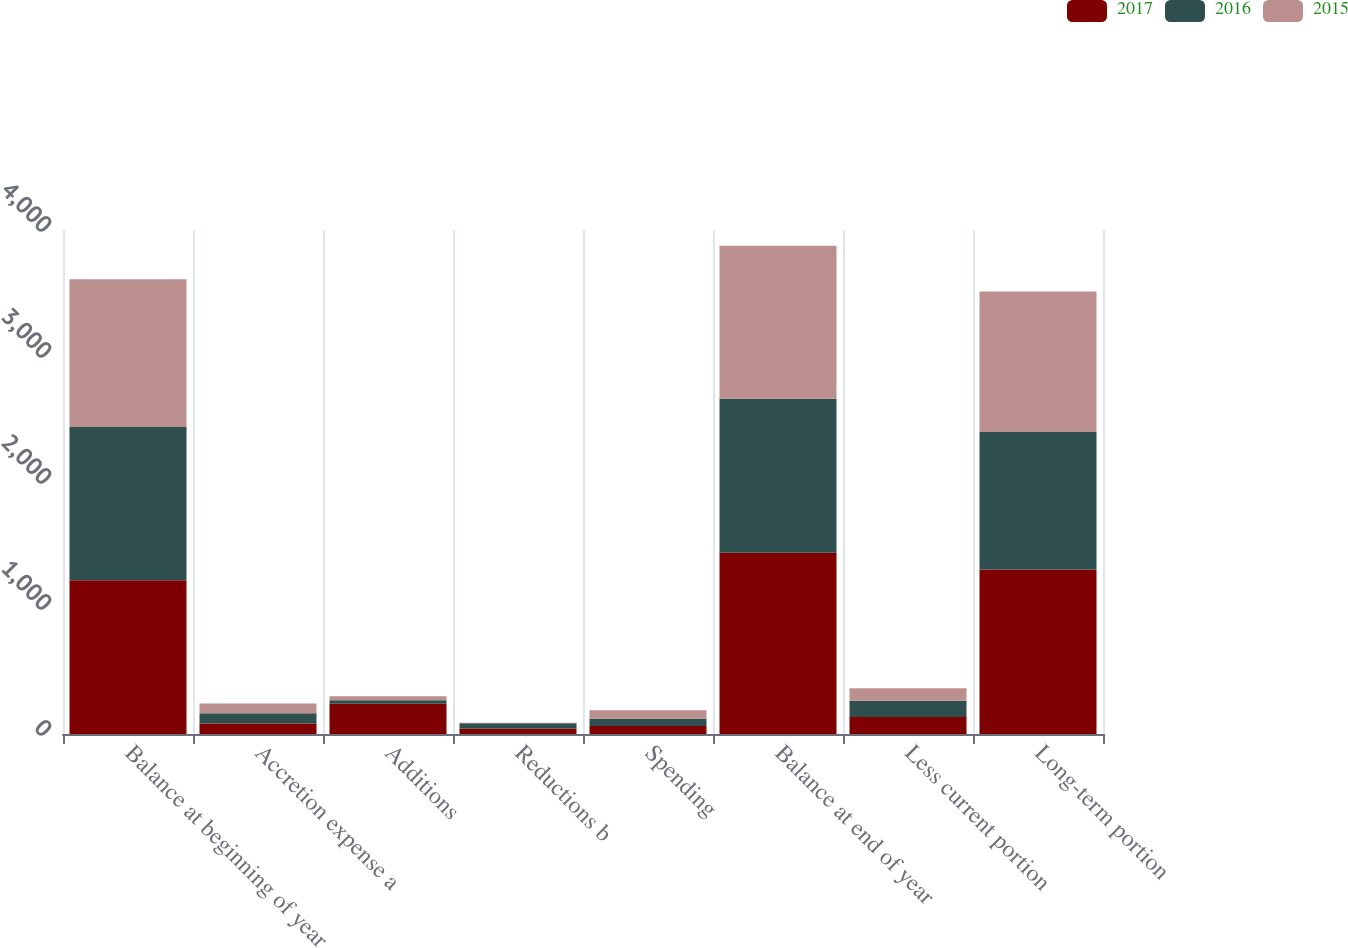Convert chart. <chart><loc_0><loc_0><loc_500><loc_500><stacked_bar_chart><ecel><fcel>Balance at beginning of year<fcel>Accretion expense a<fcel>Additions<fcel>Reductions b<fcel>Spending<fcel>Balance at end of year<fcel>Less current portion<fcel>Long-term portion<nl><fcel>2017<fcel>1221<fcel>84<fcel>241<fcel>43<fcel>64<fcel>1439<fcel>134<fcel>1305<nl><fcel>2016<fcel>1215<fcel>81<fcel>26<fcel>43<fcel>58<fcel>1221<fcel>129<fcel>1092<nl><fcel>2015<fcel>1174<fcel>78<fcel>33<fcel>3<fcel>67<fcel>1215<fcel>100<fcel>1115<nl></chart> 